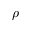<formula> <loc_0><loc_0><loc_500><loc_500>\rho</formula> 